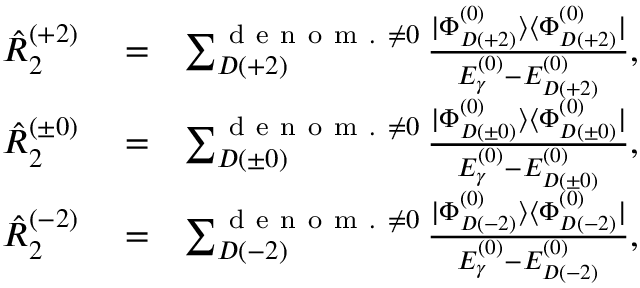Convert formula to latex. <formula><loc_0><loc_0><loc_500><loc_500>\begin{array} { r l r } { \hat { R } _ { 2 } ^ { ( + 2 ) } } & = } & { \sum _ { D ( + 2 ) } ^ { d e n o m . \neq 0 } \frac { | \Phi _ { D ( + 2 ) } ^ { ( 0 ) } \rangle \langle \Phi _ { D ( + 2 ) } ^ { ( 0 ) } | } { E _ { \gamma } ^ { ( 0 ) } - E _ { D ( + 2 ) } ^ { ( 0 ) } } , } \\ { \hat { R } _ { 2 } ^ { ( \pm 0 ) } } & = } & { \sum _ { D ( \pm 0 ) } ^ { d e n o m . \neq 0 } \frac { | \Phi _ { D ( \pm 0 ) } ^ { ( 0 ) } \rangle \langle \Phi _ { D ( \pm 0 ) } ^ { ( 0 ) } | } { E _ { \gamma } ^ { ( 0 ) } - E _ { D ( \pm 0 ) } ^ { ( 0 ) } } , } \\ { \hat { R } _ { 2 } ^ { ( - 2 ) } } & = } & { \sum _ { D ( - 2 ) } ^ { d e n o m . \neq 0 } \frac { | \Phi _ { D ( - 2 ) } ^ { ( 0 ) } \rangle \langle \Phi _ { D ( - 2 ) } ^ { ( 0 ) } | } { E _ { \gamma } ^ { ( 0 ) } - E _ { D ( - 2 ) } ^ { ( 0 ) } } , } \end{array}</formula> 